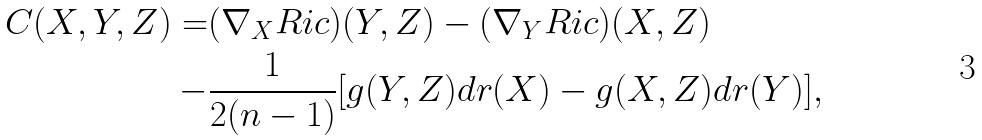Convert formula to latex. <formula><loc_0><loc_0><loc_500><loc_500>C ( X , Y , Z ) = & ( \nabla _ { X } R i c ) ( Y , Z ) - ( \nabla _ { Y } R i c ) ( X , Z ) \\ - & \frac { 1 } { 2 ( n - 1 ) } [ g ( Y , Z ) d r ( X ) - g ( X , Z ) d r ( Y ) ] ,</formula> 